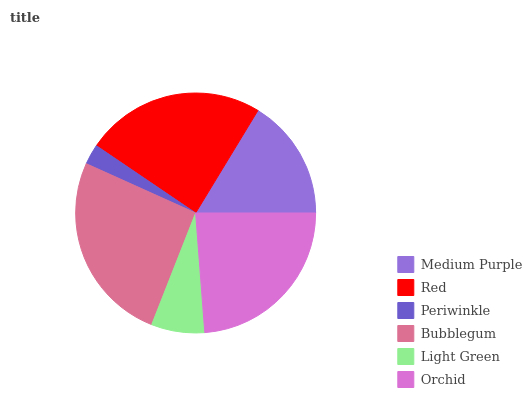Is Periwinkle the minimum?
Answer yes or no. Yes. Is Bubblegum the maximum?
Answer yes or no. Yes. Is Red the minimum?
Answer yes or no. No. Is Red the maximum?
Answer yes or no. No. Is Red greater than Medium Purple?
Answer yes or no. Yes. Is Medium Purple less than Red?
Answer yes or no. Yes. Is Medium Purple greater than Red?
Answer yes or no. No. Is Red less than Medium Purple?
Answer yes or no. No. Is Orchid the high median?
Answer yes or no. Yes. Is Medium Purple the low median?
Answer yes or no. Yes. Is Bubblegum the high median?
Answer yes or no. No. Is Bubblegum the low median?
Answer yes or no. No. 